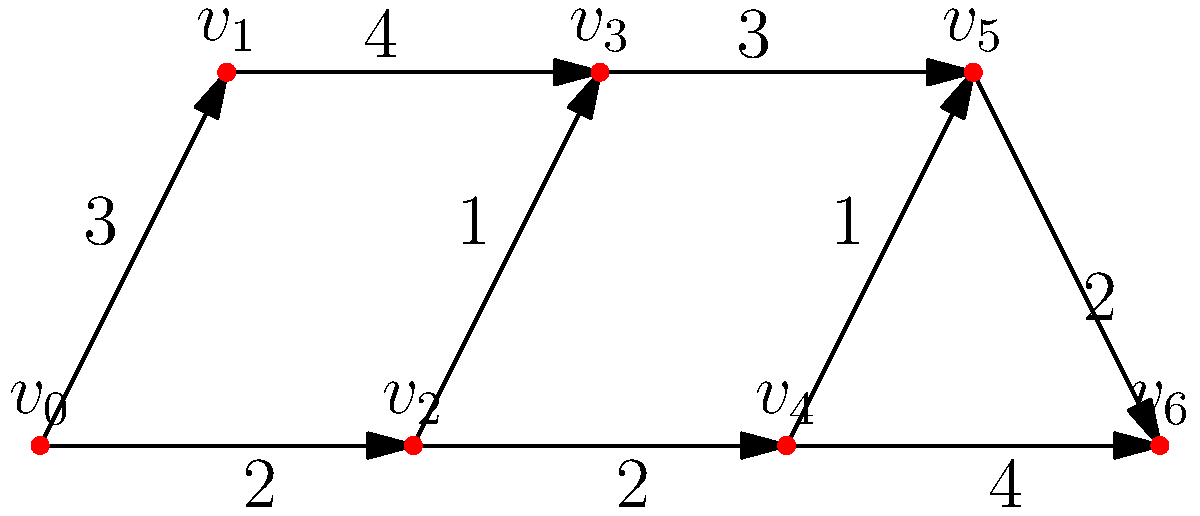As a military veteran, you're tasked with designing an efficient obstacle course for training new recruits. The course is represented by the graph above, where each vertex ($v_0$ to $v_6$) represents a checkpoint, and the edges represent paths between checkpoints with their respective difficulties (represented by the numbers on the edges). Using Dijkstra's algorithm, what is the easiest path from the start ($v_0$) to the finish ($v_6$), and what is its total difficulty? Let's apply Dijkstra's algorithm to find the shortest (easiest) path:

1) Initialize:
   - Distance to $v_0$ = 0
   - Distance to all other vertices = $\infty$
   - Previous vertex for all = undefined

2) Start at $v_0$:
   - Update $v_1$: distance = 3, previous = $v_0$
   - Update $v_2$: distance = 2, previous = $v_0$
   - Mark $v_0$ as visited

3) Choose the vertex with the smallest distance (2): $v_2$
   - Update $v_3$: distance = 2 + 1 = 3, previous = $v_2$
   - Update $v_4$: distance = 2 + 2 = 4, previous = $v_2$
   - Mark $v_2$ as visited

4) Choose the vertex with the smallest distance (3): $v_1$ or $v_3$ (choose $v_3$)
   - Update $v_5$: distance = 3 + 3 = 6, previous = $v_3$
   - Mark $v_3$ as visited

5) Choose $v_1$ (distance = 3):
   - No updates needed
   - Mark $v_1$ as visited

6) Choose $v_4$ (distance = 4):
   - Update $v_5$: distance = 4 + 1 = 5 (better than 6), previous = $v_4$
   - Update $v_6$: distance = 4 + 4 = 8, previous = $v_4$
   - Mark $v_4$ as visited

7) Choose $v_5$ (distance = 5):
   - Update $v_6$: distance = 5 + 2 = 7 (better than 8), previous = $v_5$
   - Mark $v_5$ as visited

8) Choose $v_6$ (distance = 7):
   - Algorithm complete

The easiest path is $v_0 \rightarrow v_2 \rightarrow v_4 \rightarrow v_5 \rightarrow v_6$ with a total difficulty of 7.
Answer: $v_0 \rightarrow v_2 \rightarrow v_4 \rightarrow v_5 \rightarrow v_6$; Total difficulty: 7 